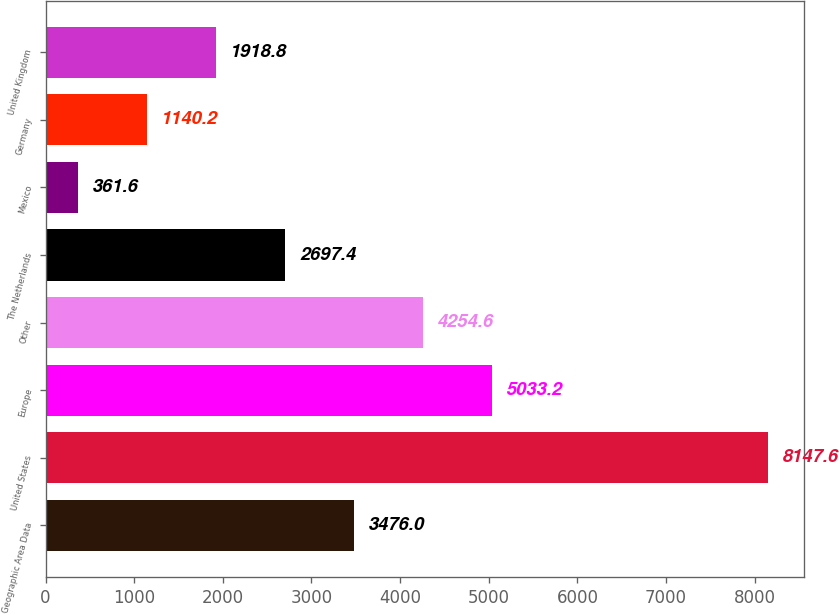Convert chart to OTSL. <chart><loc_0><loc_0><loc_500><loc_500><bar_chart><fcel>Geographic Area Data<fcel>United States<fcel>Europe<fcel>Other<fcel>The Netherlands<fcel>Mexico<fcel>Germany<fcel>United Kingdom<nl><fcel>3476<fcel>8147.6<fcel>5033.2<fcel>4254.6<fcel>2697.4<fcel>361.6<fcel>1140.2<fcel>1918.8<nl></chart> 